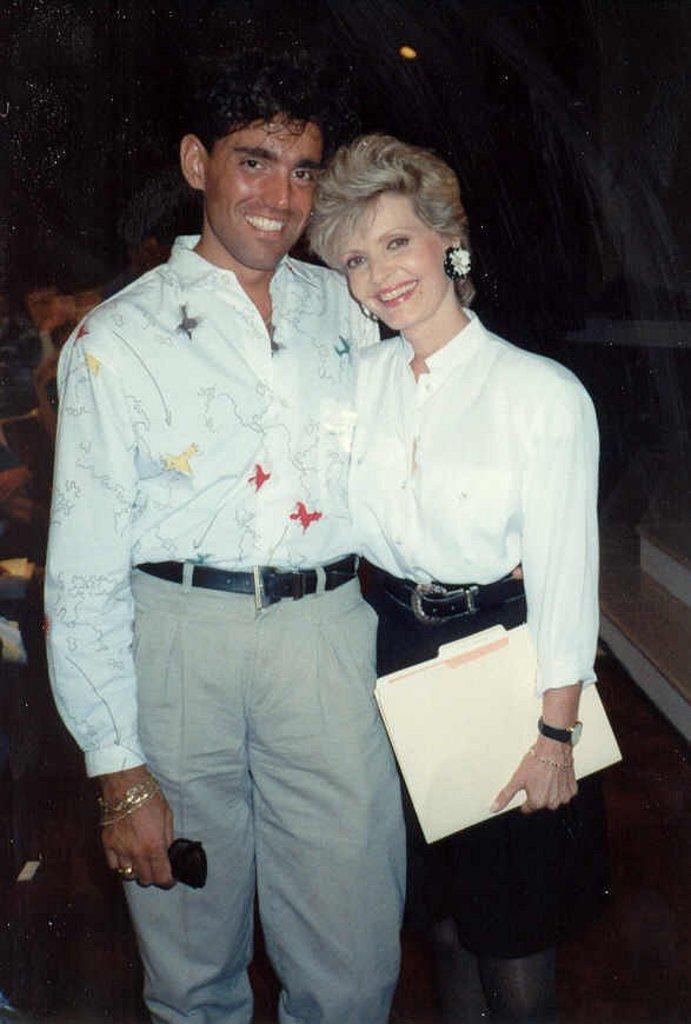Please provide a concise description of this image. In the foreground of the image we can see two persons standing. One woman is holding a file in her hand. One person is holding goggles with his hand. In the background, we can see some objects placed on the ground, stairs and some lights. 